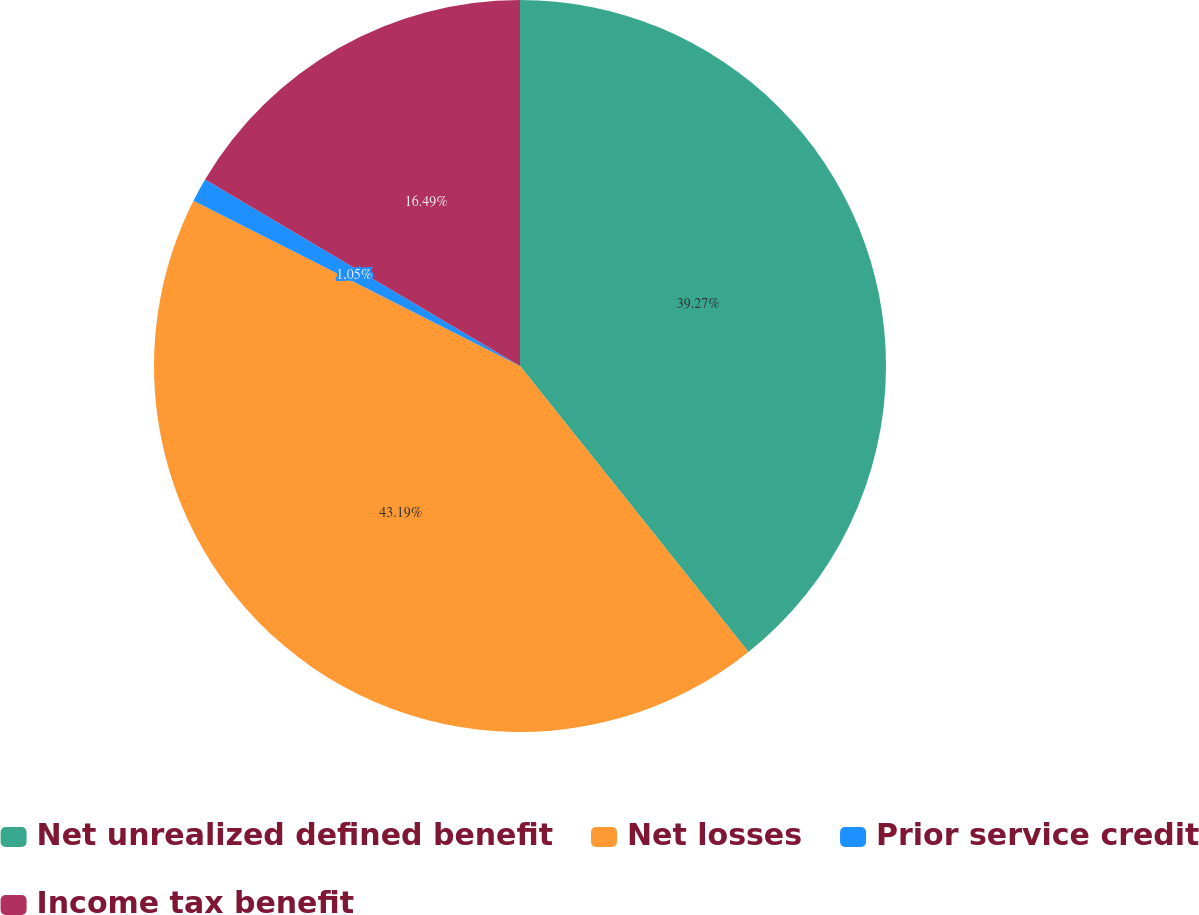Convert chart to OTSL. <chart><loc_0><loc_0><loc_500><loc_500><pie_chart><fcel>Net unrealized defined benefit<fcel>Net losses<fcel>Prior service credit<fcel>Income tax benefit<nl><fcel>39.27%<fcel>43.19%<fcel>1.05%<fcel>16.49%<nl></chart> 